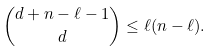<formula> <loc_0><loc_0><loc_500><loc_500>\binom { d + n - \ell - 1 } { d } \leq \ell ( n - \ell ) .</formula> 